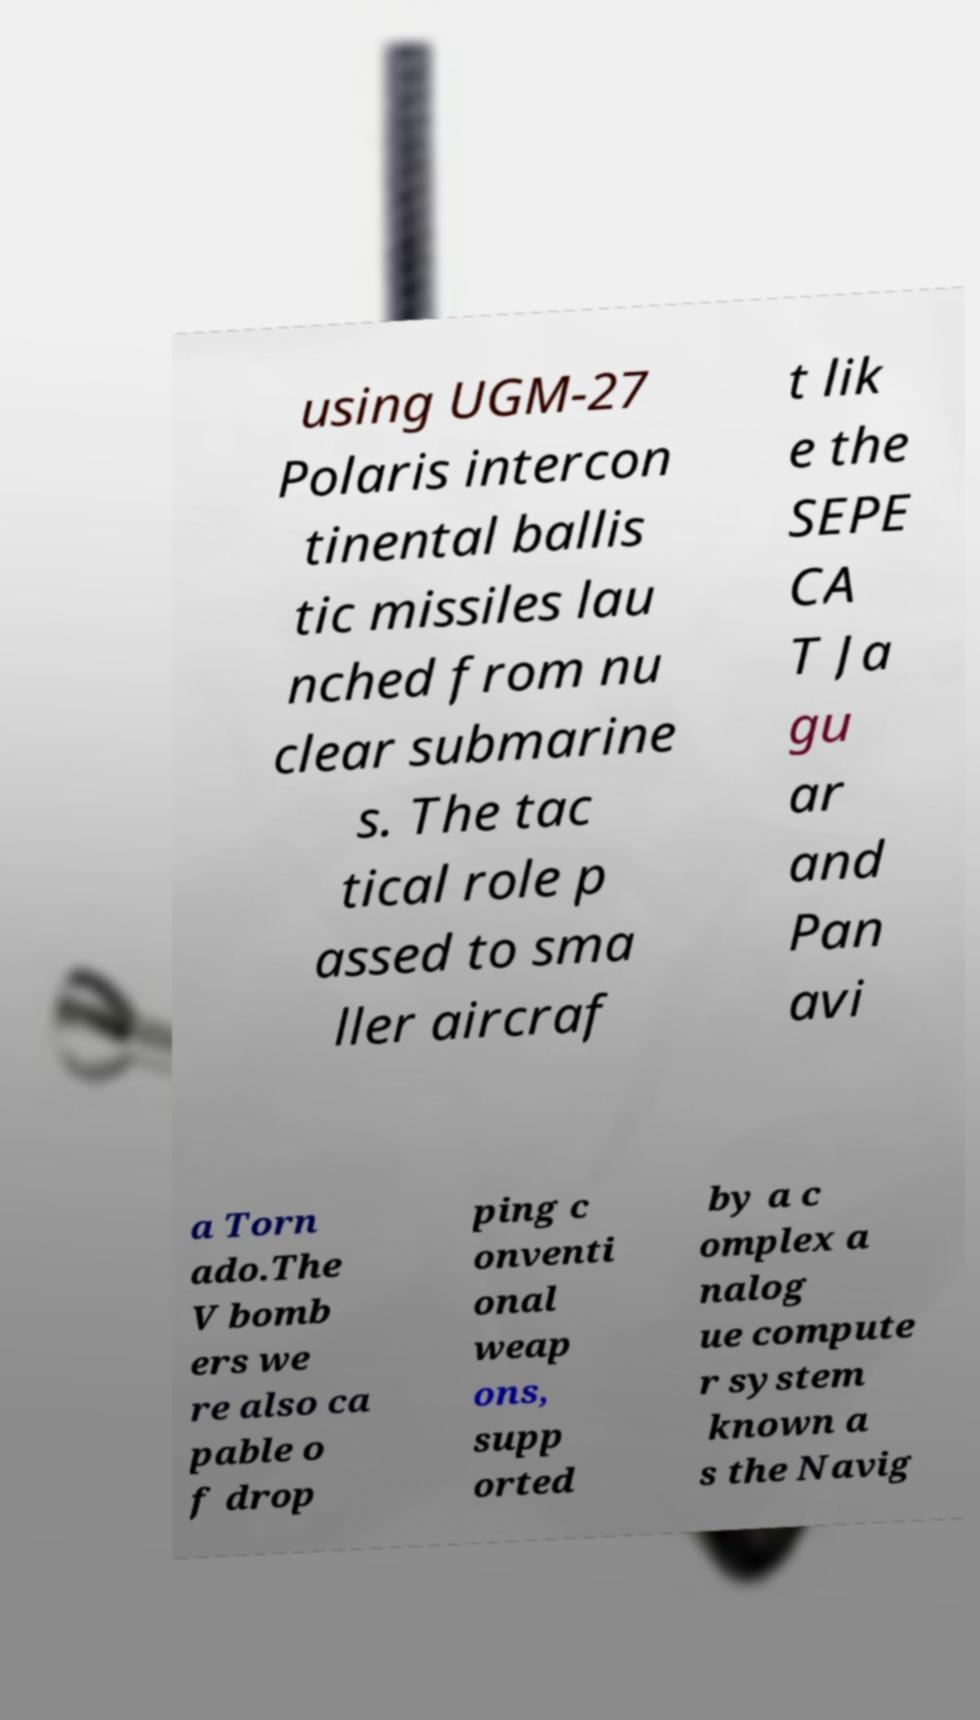Could you assist in decoding the text presented in this image and type it out clearly? using UGM-27 Polaris intercon tinental ballis tic missiles lau nched from nu clear submarine s. The tac tical role p assed to sma ller aircraf t lik e the SEPE CA T Ja gu ar and Pan avi a Torn ado.The V bomb ers we re also ca pable o f drop ping c onventi onal weap ons, supp orted by a c omplex a nalog ue compute r system known a s the Navig 